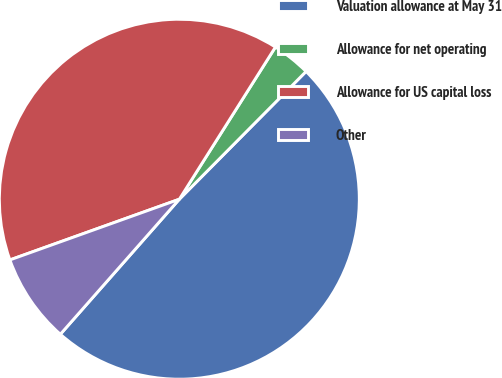Convert chart to OTSL. <chart><loc_0><loc_0><loc_500><loc_500><pie_chart><fcel>Valuation allowance at May 31<fcel>Allowance for net operating<fcel>Allowance for US capital loss<fcel>Other<nl><fcel>49.06%<fcel>3.47%<fcel>39.44%<fcel>8.03%<nl></chart> 